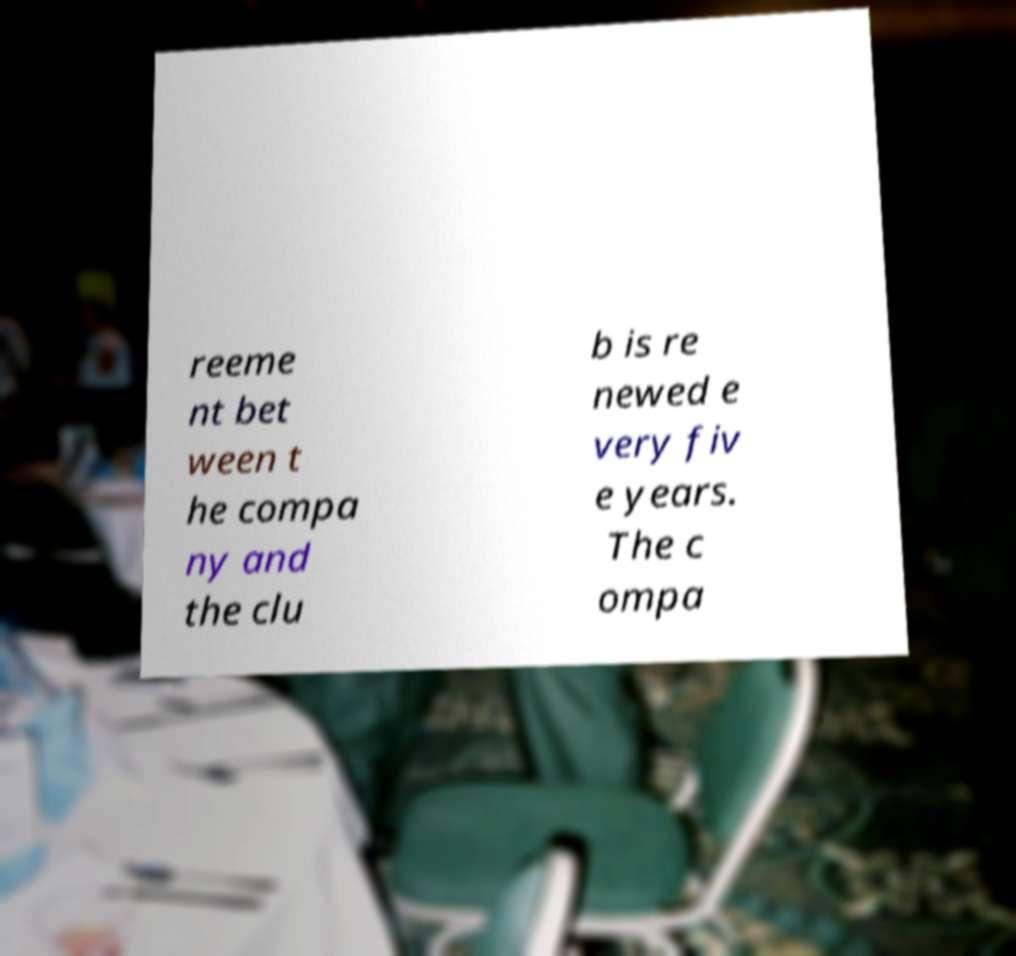Can you read and provide the text displayed in the image?This photo seems to have some interesting text. Can you extract and type it out for me? reeme nt bet ween t he compa ny and the clu b is re newed e very fiv e years. The c ompa 